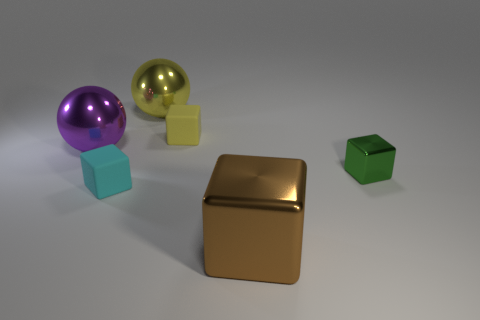What shape is the small green object on the right side of the small matte object to the right of the tiny rubber cube in front of the small yellow matte thing?
Ensure brevity in your answer.  Cube. What number of tiny objects are on the right side of the large shiny cube?
Offer a terse response. 1. Does the yellow object that is left of the tiny yellow object have the same material as the block behind the purple object?
Offer a very short reply. No. How many objects are big metal spheres that are in front of the yellow block or big purple metal cylinders?
Your answer should be very brief. 1. Is the number of rubber blocks that are behind the tiny yellow block less than the number of yellow matte objects that are in front of the purple metallic thing?
Keep it short and to the point. No. How many other objects are there of the same size as the brown shiny block?
Your response must be concise. 2. Do the tiny yellow object and the tiny object that is in front of the green shiny thing have the same material?
Your answer should be compact. Yes. What number of objects are either small things that are to the left of the yellow shiny sphere or metallic things behind the cyan matte block?
Keep it short and to the point. 4. What color is the small metal object?
Provide a short and direct response. Green. Are there fewer yellow rubber things that are in front of the small cyan rubber block than small green shiny things?
Your answer should be compact. Yes. 